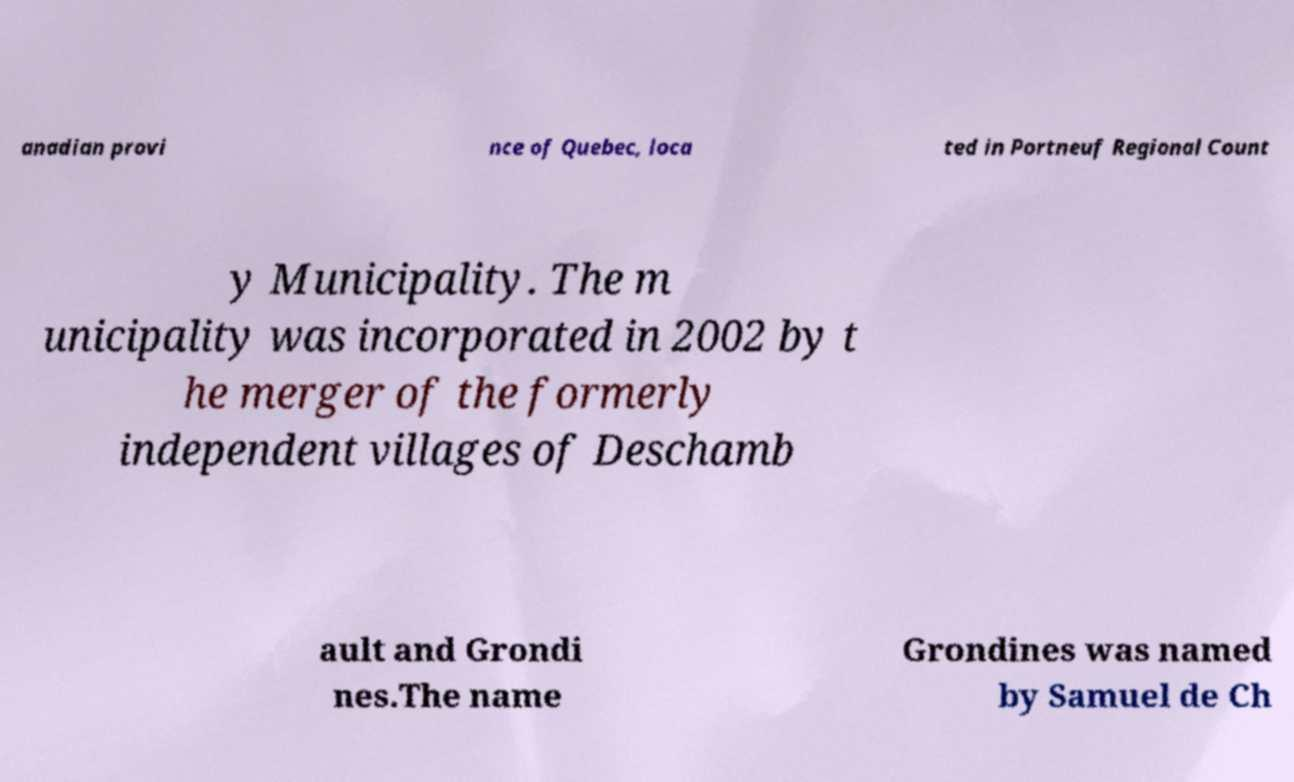For documentation purposes, I need the text within this image transcribed. Could you provide that? anadian provi nce of Quebec, loca ted in Portneuf Regional Count y Municipality. The m unicipality was incorporated in 2002 by t he merger of the formerly independent villages of Deschamb ault and Grondi nes.The name Grondines was named by Samuel de Ch 